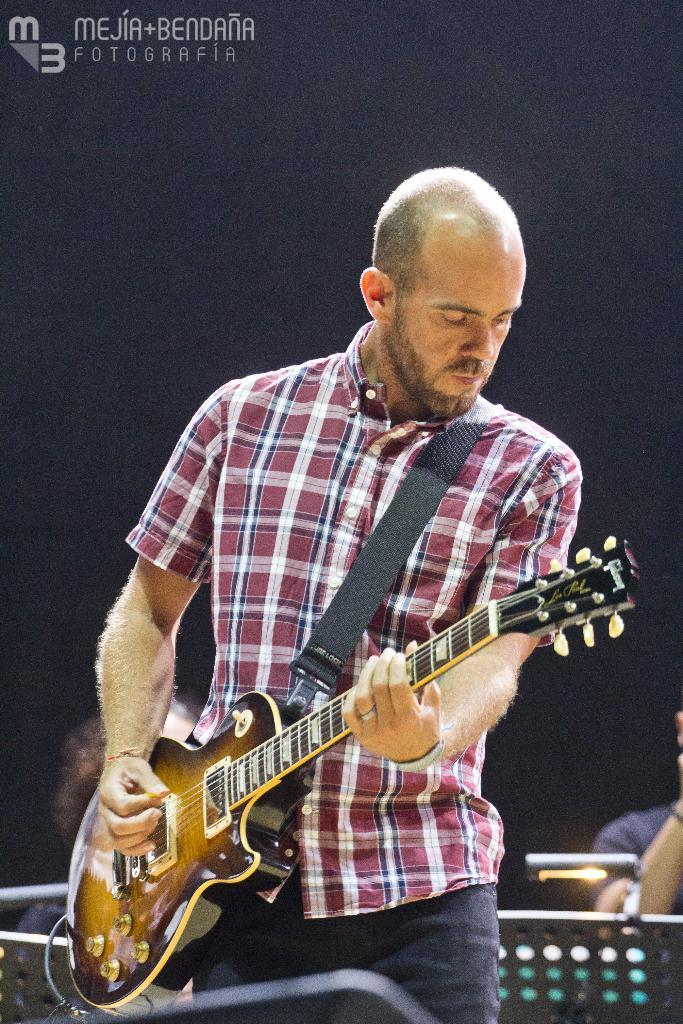Who is the main subject in the image? There is a man in the image. What is the man doing in the image? The man is standing and holding a guitar. Can you describe the background of the image? There are two persons in the background of the image. What type of control does the man have over the guitar in the image? The image does not show the man playing the guitar, so it is not possible to determine the type of control he has over it. 